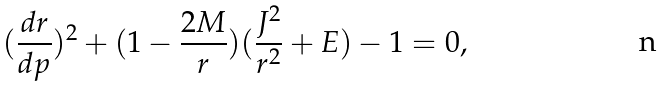<formula> <loc_0><loc_0><loc_500><loc_500>( \frac { d r } { d p } ) ^ { 2 } + ( 1 - \frac { 2 M } { r } ) ( \frac { J ^ { 2 } } { r ^ { 2 } } + E ) - 1 = 0 ,</formula> 